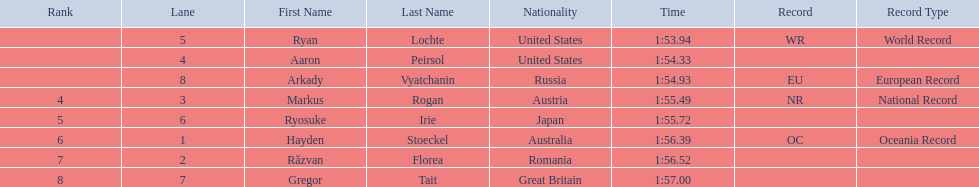What is the name of the contestant in lane 6? Ryosuke Irie. How long did it take that player to complete the race? 1:55.72. 